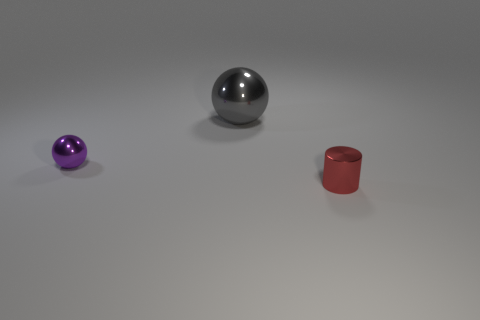Add 1 big gray shiny objects. How many objects exist? 4 Subtract all gray spheres. Subtract all red cubes. How many spheres are left? 1 Subtract all blue cubes. How many cyan cylinders are left? 0 Subtract all brown rubber objects. Subtract all purple things. How many objects are left? 2 Add 1 tiny purple shiny balls. How many tiny purple shiny balls are left? 2 Add 2 tiny red cylinders. How many tiny red cylinders exist? 3 Subtract 0 purple cubes. How many objects are left? 3 Subtract all cylinders. How many objects are left? 2 